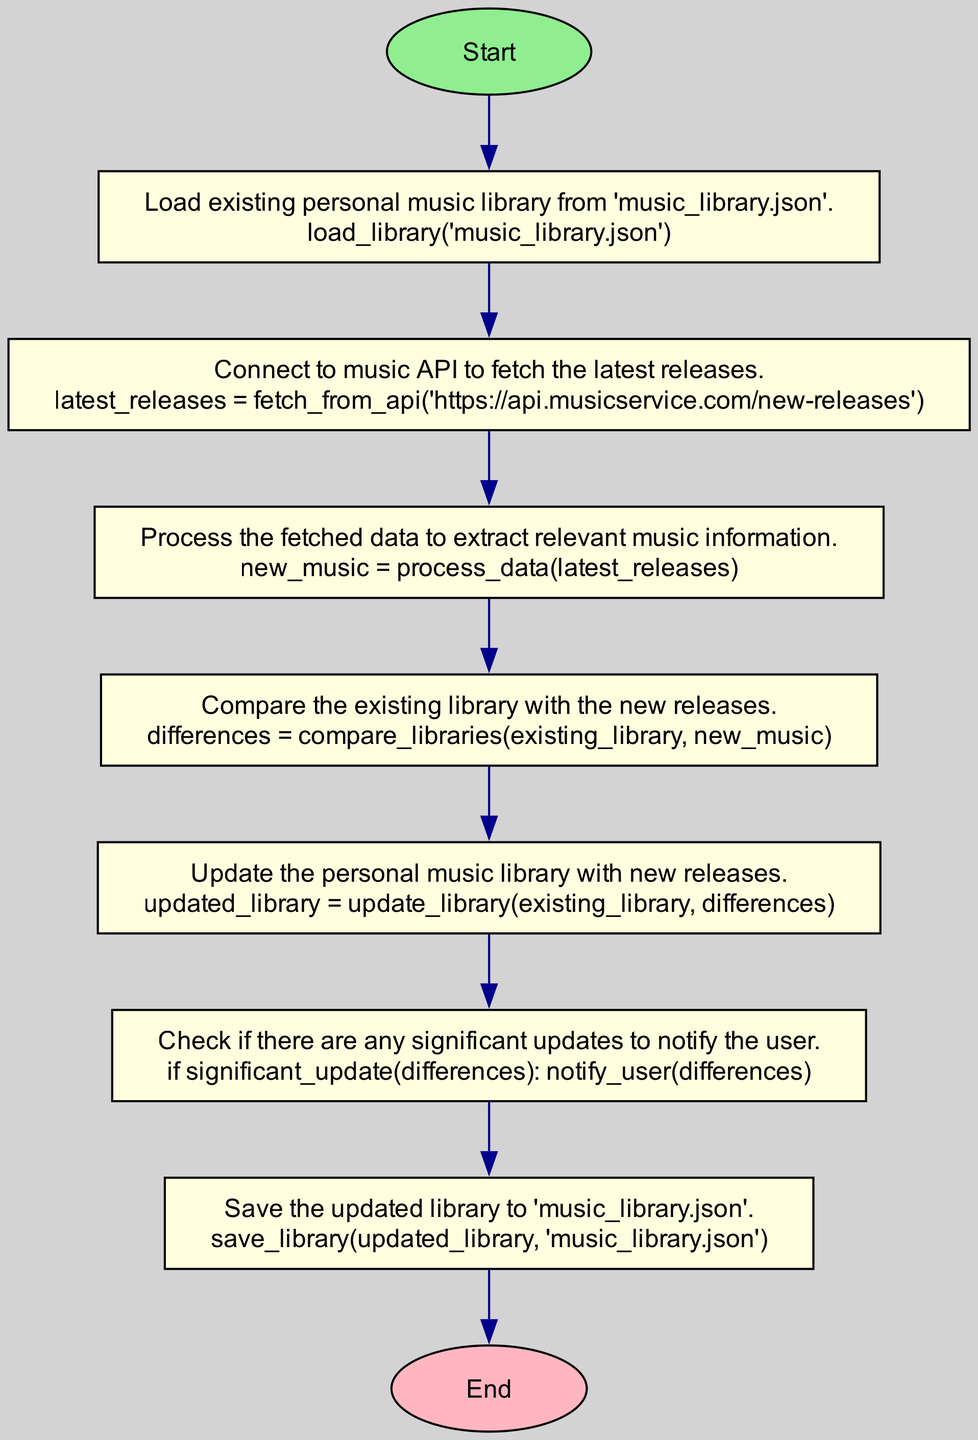What is the first step in the flowchart? The first step in the flowchart is to "Load existing personal music library from 'music_library.json'." This is indicated after the start node, which points directly to the check_existing_library node.
Answer: Load existing personal music library from 'music_library.json' How many processes are in the flowchart? By counting the rectangular nodes between the start and end nodes, there are 6 processes: check_existing_library, fetch_latest_releases, process_releases, compare_libraries, update_library, and check_for_notification.
Answer: 6 What action corresponds to the process 'process_releases'? The action associated with the process 'process_releases' is "new_music = process_data(latest_releases)". This can be found in the description of the process node for 'process_releases'.
Answer: new_music = process_data(latest_releases) What is the last action performed before saving the updated library? The last action before saving is "Check if there are any significant updates to notify the user." This is found in the check_for_notification node which occurs just before the save_updated_library process.
Answer: Check if there are any significant updates to notify the user Which node comes after 'update_library'? The node that directly follows 'update_library' is 'check_for_notification', indicating that after the update process, the system checks for any notifications regarding significant updates.
Answer: check_for_notification What is the relationship between 'fetch_latest_releases' and 'process_releases'? The relationship is a sequential flow where after the action of fetching the latest releases is complete (in 'fetch_latest_releases'), the next step is to process those releases (in 'process_releases'). This is indicated by the direct edge from the former node to the latter in the flowchart.
Answer: Sequential flow What happens if there are significant updates found? If significant updates are found, the user is notified, which is part of the action taken in the check_for_notification process. This process checks for such updates before proceeding to save the updated library.
Answer: Notify the user 